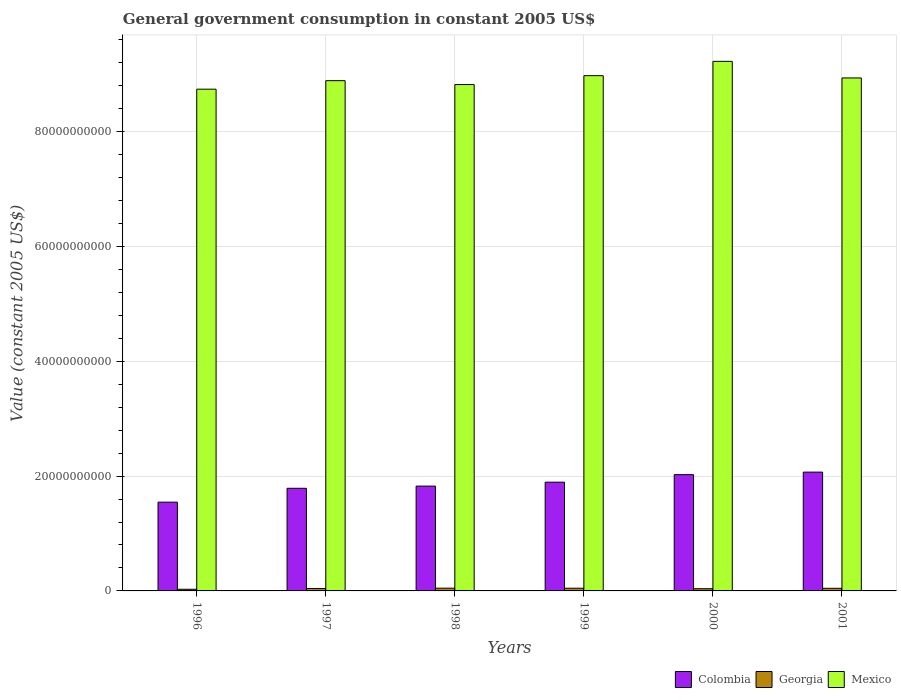How many different coloured bars are there?
Give a very brief answer. 3. Are the number of bars per tick equal to the number of legend labels?
Offer a very short reply. Yes. Are the number of bars on each tick of the X-axis equal?
Make the answer very short. Yes. What is the label of the 3rd group of bars from the left?
Ensure brevity in your answer.  1998. In how many cases, is the number of bars for a given year not equal to the number of legend labels?
Offer a very short reply. 0. What is the government conusmption in Georgia in 1999?
Provide a succinct answer. 4.70e+08. Across all years, what is the maximum government conusmption in Georgia?
Provide a succinct answer. 4.76e+08. Across all years, what is the minimum government conusmption in Mexico?
Ensure brevity in your answer.  8.74e+1. In which year was the government conusmption in Georgia minimum?
Provide a short and direct response. 1996. What is the total government conusmption in Colombia in the graph?
Your answer should be very brief. 1.11e+11. What is the difference between the government conusmption in Georgia in 1997 and that in 2000?
Provide a short and direct response. 3.94e+07. What is the difference between the government conusmption in Mexico in 2000 and the government conusmption in Colombia in 2001?
Offer a very short reply. 7.15e+1. What is the average government conusmption in Mexico per year?
Offer a very short reply. 8.93e+1. In the year 1997, what is the difference between the government conusmption in Georgia and government conusmption in Colombia?
Offer a very short reply. -1.75e+1. What is the ratio of the government conusmption in Georgia in 1996 to that in 1999?
Your answer should be compact. 0.62. Is the government conusmption in Mexico in 1997 less than that in 1998?
Make the answer very short. No. What is the difference between the highest and the second highest government conusmption in Colombia?
Give a very brief answer. 4.44e+08. What is the difference between the highest and the lowest government conusmption in Mexico?
Offer a terse response. 4.85e+09. In how many years, is the government conusmption in Mexico greater than the average government conusmption in Mexico taken over all years?
Ensure brevity in your answer.  3. Is the sum of the government conusmption in Georgia in 2000 and 2001 greater than the maximum government conusmption in Mexico across all years?
Provide a short and direct response. No. What does the 2nd bar from the left in 2001 represents?
Your answer should be very brief. Georgia. What does the 1st bar from the right in 2001 represents?
Your answer should be compact. Mexico. How many bars are there?
Provide a succinct answer. 18. Are all the bars in the graph horizontal?
Give a very brief answer. No. What is the difference between two consecutive major ticks on the Y-axis?
Your response must be concise. 2.00e+1. Are the values on the major ticks of Y-axis written in scientific E-notation?
Give a very brief answer. No. Where does the legend appear in the graph?
Your answer should be very brief. Bottom right. What is the title of the graph?
Provide a short and direct response. General government consumption in constant 2005 US$. Does "Kyrgyz Republic" appear as one of the legend labels in the graph?
Your response must be concise. No. What is the label or title of the Y-axis?
Your answer should be very brief. Value (constant 2005 US$). What is the Value (constant 2005 US$) of Colombia in 1996?
Offer a very short reply. 1.55e+1. What is the Value (constant 2005 US$) in Georgia in 1996?
Offer a terse response. 2.90e+08. What is the Value (constant 2005 US$) in Mexico in 1996?
Your answer should be compact. 8.74e+1. What is the Value (constant 2005 US$) of Colombia in 1997?
Your answer should be compact. 1.79e+1. What is the Value (constant 2005 US$) of Georgia in 1997?
Your answer should be compact. 4.24e+08. What is the Value (constant 2005 US$) of Mexico in 1997?
Make the answer very short. 8.89e+1. What is the Value (constant 2005 US$) of Colombia in 1998?
Keep it short and to the point. 1.83e+1. What is the Value (constant 2005 US$) of Georgia in 1998?
Your answer should be compact. 4.76e+08. What is the Value (constant 2005 US$) in Mexico in 1998?
Ensure brevity in your answer.  8.82e+1. What is the Value (constant 2005 US$) of Colombia in 1999?
Provide a short and direct response. 1.89e+1. What is the Value (constant 2005 US$) in Georgia in 1999?
Give a very brief answer. 4.70e+08. What is the Value (constant 2005 US$) in Mexico in 1999?
Offer a very short reply. 8.98e+1. What is the Value (constant 2005 US$) of Colombia in 2000?
Give a very brief answer. 2.03e+1. What is the Value (constant 2005 US$) of Georgia in 2000?
Provide a succinct answer. 3.84e+08. What is the Value (constant 2005 US$) of Mexico in 2000?
Make the answer very short. 9.22e+1. What is the Value (constant 2005 US$) of Colombia in 2001?
Offer a terse response. 2.07e+1. What is the Value (constant 2005 US$) of Georgia in 2001?
Your answer should be very brief. 4.55e+08. What is the Value (constant 2005 US$) in Mexico in 2001?
Ensure brevity in your answer.  8.94e+1. Across all years, what is the maximum Value (constant 2005 US$) in Colombia?
Ensure brevity in your answer.  2.07e+1. Across all years, what is the maximum Value (constant 2005 US$) of Georgia?
Offer a terse response. 4.76e+08. Across all years, what is the maximum Value (constant 2005 US$) in Mexico?
Ensure brevity in your answer.  9.22e+1. Across all years, what is the minimum Value (constant 2005 US$) of Colombia?
Offer a terse response. 1.55e+1. Across all years, what is the minimum Value (constant 2005 US$) of Georgia?
Offer a terse response. 2.90e+08. Across all years, what is the minimum Value (constant 2005 US$) in Mexico?
Keep it short and to the point. 8.74e+1. What is the total Value (constant 2005 US$) of Colombia in the graph?
Offer a terse response. 1.11e+11. What is the total Value (constant 2005 US$) in Georgia in the graph?
Ensure brevity in your answer.  2.50e+09. What is the total Value (constant 2005 US$) of Mexico in the graph?
Give a very brief answer. 5.36e+11. What is the difference between the Value (constant 2005 US$) of Colombia in 1996 and that in 1997?
Give a very brief answer. -2.42e+09. What is the difference between the Value (constant 2005 US$) in Georgia in 1996 and that in 1997?
Provide a short and direct response. -1.34e+08. What is the difference between the Value (constant 2005 US$) of Mexico in 1996 and that in 1997?
Provide a short and direct response. -1.48e+09. What is the difference between the Value (constant 2005 US$) of Colombia in 1996 and that in 1998?
Keep it short and to the point. -2.80e+09. What is the difference between the Value (constant 2005 US$) in Georgia in 1996 and that in 1998?
Provide a succinct answer. -1.86e+08. What is the difference between the Value (constant 2005 US$) of Mexico in 1996 and that in 1998?
Your response must be concise. -8.05e+08. What is the difference between the Value (constant 2005 US$) of Colombia in 1996 and that in 1999?
Give a very brief answer. -3.48e+09. What is the difference between the Value (constant 2005 US$) in Georgia in 1996 and that in 1999?
Your answer should be compact. -1.80e+08. What is the difference between the Value (constant 2005 US$) in Mexico in 1996 and that in 1999?
Your answer should be compact. -2.35e+09. What is the difference between the Value (constant 2005 US$) of Colombia in 1996 and that in 2000?
Ensure brevity in your answer.  -4.79e+09. What is the difference between the Value (constant 2005 US$) in Georgia in 1996 and that in 2000?
Offer a very short reply. -9.41e+07. What is the difference between the Value (constant 2005 US$) of Mexico in 1996 and that in 2000?
Your answer should be very brief. -4.85e+09. What is the difference between the Value (constant 2005 US$) of Colombia in 1996 and that in 2001?
Provide a short and direct response. -5.23e+09. What is the difference between the Value (constant 2005 US$) of Georgia in 1996 and that in 2001?
Make the answer very short. -1.65e+08. What is the difference between the Value (constant 2005 US$) of Mexico in 1996 and that in 2001?
Keep it short and to the point. -1.96e+09. What is the difference between the Value (constant 2005 US$) in Colombia in 1997 and that in 1998?
Your answer should be compact. -3.82e+08. What is the difference between the Value (constant 2005 US$) of Georgia in 1997 and that in 1998?
Offer a terse response. -5.24e+07. What is the difference between the Value (constant 2005 US$) of Mexico in 1997 and that in 1998?
Your answer should be compact. 6.76e+08. What is the difference between the Value (constant 2005 US$) in Colombia in 1997 and that in 1999?
Offer a very short reply. -1.07e+09. What is the difference between the Value (constant 2005 US$) of Georgia in 1997 and that in 1999?
Your answer should be very brief. -4.62e+07. What is the difference between the Value (constant 2005 US$) in Mexico in 1997 and that in 1999?
Your answer should be very brief. -8.73e+08. What is the difference between the Value (constant 2005 US$) of Colombia in 1997 and that in 2000?
Offer a terse response. -2.38e+09. What is the difference between the Value (constant 2005 US$) in Georgia in 1997 and that in 2000?
Ensure brevity in your answer.  3.94e+07. What is the difference between the Value (constant 2005 US$) in Mexico in 1997 and that in 2000?
Give a very brief answer. -3.36e+09. What is the difference between the Value (constant 2005 US$) of Colombia in 1997 and that in 2001?
Provide a short and direct response. -2.82e+09. What is the difference between the Value (constant 2005 US$) of Georgia in 1997 and that in 2001?
Offer a terse response. -3.12e+07. What is the difference between the Value (constant 2005 US$) of Mexico in 1997 and that in 2001?
Your answer should be very brief. -4.74e+08. What is the difference between the Value (constant 2005 US$) of Colombia in 1998 and that in 1999?
Keep it short and to the point. -6.83e+08. What is the difference between the Value (constant 2005 US$) of Georgia in 1998 and that in 1999?
Provide a succinct answer. 6.24e+06. What is the difference between the Value (constant 2005 US$) in Mexico in 1998 and that in 1999?
Give a very brief answer. -1.55e+09. What is the difference between the Value (constant 2005 US$) in Colombia in 1998 and that in 2000?
Your answer should be compact. -1.99e+09. What is the difference between the Value (constant 2005 US$) in Georgia in 1998 and that in 2000?
Offer a very short reply. 9.19e+07. What is the difference between the Value (constant 2005 US$) of Mexico in 1998 and that in 2000?
Your answer should be compact. -4.04e+09. What is the difference between the Value (constant 2005 US$) in Colombia in 1998 and that in 2001?
Give a very brief answer. -2.44e+09. What is the difference between the Value (constant 2005 US$) of Georgia in 1998 and that in 2001?
Make the answer very short. 2.13e+07. What is the difference between the Value (constant 2005 US$) in Mexico in 1998 and that in 2001?
Your answer should be very brief. -1.15e+09. What is the difference between the Value (constant 2005 US$) in Colombia in 1999 and that in 2000?
Your answer should be compact. -1.31e+09. What is the difference between the Value (constant 2005 US$) of Georgia in 1999 and that in 2000?
Give a very brief answer. 8.56e+07. What is the difference between the Value (constant 2005 US$) of Mexico in 1999 and that in 2000?
Keep it short and to the point. -2.49e+09. What is the difference between the Value (constant 2005 US$) of Colombia in 1999 and that in 2001?
Offer a very short reply. -1.75e+09. What is the difference between the Value (constant 2005 US$) in Georgia in 1999 and that in 2001?
Keep it short and to the point. 1.50e+07. What is the difference between the Value (constant 2005 US$) of Mexico in 1999 and that in 2001?
Provide a succinct answer. 3.99e+08. What is the difference between the Value (constant 2005 US$) in Colombia in 2000 and that in 2001?
Offer a terse response. -4.44e+08. What is the difference between the Value (constant 2005 US$) in Georgia in 2000 and that in 2001?
Give a very brief answer. -7.06e+07. What is the difference between the Value (constant 2005 US$) in Mexico in 2000 and that in 2001?
Provide a succinct answer. 2.89e+09. What is the difference between the Value (constant 2005 US$) of Colombia in 1996 and the Value (constant 2005 US$) of Georgia in 1997?
Provide a succinct answer. 1.50e+1. What is the difference between the Value (constant 2005 US$) of Colombia in 1996 and the Value (constant 2005 US$) of Mexico in 1997?
Your answer should be compact. -7.34e+1. What is the difference between the Value (constant 2005 US$) of Georgia in 1996 and the Value (constant 2005 US$) of Mexico in 1997?
Provide a short and direct response. -8.86e+1. What is the difference between the Value (constant 2005 US$) in Colombia in 1996 and the Value (constant 2005 US$) in Georgia in 1998?
Offer a very short reply. 1.50e+1. What is the difference between the Value (constant 2005 US$) of Colombia in 1996 and the Value (constant 2005 US$) of Mexico in 1998?
Make the answer very short. -7.27e+1. What is the difference between the Value (constant 2005 US$) in Georgia in 1996 and the Value (constant 2005 US$) in Mexico in 1998?
Your answer should be compact. -8.79e+1. What is the difference between the Value (constant 2005 US$) of Colombia in 1996 and the Value (constant 2005 US$) of Georgia in 1999?
Your answer should be very brief. 1.50e+1. What is the difference between the Value (constant 2005 US$) in Colombia in 1996 and the Value (constant 2005 US$) in Mexico in 1999?
Keep it short and to the point. -7.43e+1. What is the difference between the Value (constant 2005 US$) of Georgia in 1996 and the Value (constant 2005 US$) of Mexico in 1999?
Ensure brevity in your answer.  -8.95e+1. What is the difference between the Value (constant 2005 US$) in Colombia in 1996 and the Value (constant 2005 US$) in Georgia in 2000?
Make the answer very short. 1.51e+1. What is the difference between the Value (constant 2005 US$) of Colombia in 1996 and the Value (constant 2005 US$) of Mexico in 2000?
Your answer should be compact. -7.68e+1. What is the difference between the Value (constant 2005 US$) of Georgia in 1996 and the Value (constant 2005 US$) of Mexico in 2000?
Ensure brevity in your answer.  -9.20e+1. What is the difference between the Value (constant 2005 US$) in Colombia in 1996 and the Value (constant 2005 US$) in Georgia in 2001?
Provide a succinct answer. 1.50e+1. What is the difference between the Value (constant 2005 US$) of Colombia in 1996 and the Value (constant 2005 US$) of Mexico in 2001?
Offer a terse response. -7.39e+1. What is the difference between the Value (constant 2005 US$) of Georgia in 1996 and the Value (constant 2005 US$) of Mexico in 2001?
Make the answer very short. -8.91e+1. What is the difference between the Value (constant 2005 US$) in Colombia in 1997 and the Value (constant 2005 US$) in Georgia in 1998?
Give a very brief answer. 1.74e+1. What is the difference between the Value (constant 2005 US$) of Colombia in 1997 and the Value (constant 2005 US$) of Mexico in 1998?
Offer a terse response. -7.03e+1. What is the difference between the Value (constant 2005 US$) in Georgia in 1997 and the Value (constant 2005 US$) in Mexico in 1998?
Your answer should be very brief. -8.78e+1. What is the difference between the Value (constant 2005 US$) in Colombia in 1997 and the Value (constant 2005 US$) in Georgia in 1999?
Provide a short and direct response. 1.74e+1. What is the difference between the Value (constant 2005 US$) in Colombia in 1997 and the Value (constant 2005 US$) in Mexico in 1999?
Your response must be concise. -7.19e+1. What is the difference between the Value (constant 2005 US$) of Georgia in 1997 and the Value (constant 2005 US$) of Mexico in 1999?
Provide a succinct answer. -8.93e+1. What is the difference between the Value (constant 2005 US$) in Colombia in 1997 and the Value (constant 2005 US$) in Georgia in 2000?
Provide a short and direct response. 1.75e+1. What is the difference between the Value (constant 2005 US$) in Colombia in 1997 and the Value (constant 2005 US$) in Mexico in 2000?
Provide a succinct answer. -7.44e+1. What is the difference between the Value (constant 2005 US$) in Georgia in 1997 and the Value (constant 2005 US$) in Mexico in 2000?
Keep it short and to the point. -9.18e+1. What is the difference between the Value (constant 2005 US$) of Colombia in 1997 and the Value (constant 2005 US$) of Georgia in 2001?
Provide a succinct answer. 1.74e+1. What is the difference between the Value (constant 2005 US$) of Colombia in 1997 and the Value (constant 2005 US$) of Mexico in 2001?
Make the answer very short. -7.15e+1. What is the difference between the Value (constant 2005 US$) of Georgia in 1997 and the Value (constant 2005 US$) of Mexico in 2001?
Keep it short and to the point. -8.89e+1. What is the difference between the Value (constant 2005 US$) in Colombia in 1998 and the Value (constant 2005 US$) in Georgia in 1999?
Keep it short and to the point. 1.78e+1. What is the difference between the Value (constant 2005 US$) in Colombia in 1998 and the Value (constant 2005 US$) in Mexico in 1999?
Make the answer very short. -7.15e+1. What is the difference between the Value (constant 2005 US$) of Georgia in 1998 and the Value (constant 2005 US$) of Mexico in 1999?
Give a very brief answer. -8.93e+1. What is the difference between the Value (constant 2005 US$) in Colombia in 1998 and the Value (constant 2005 US$) in Georgia in 2000?
Offer a terse response. 1.79e+1. What is the difference between the Value (constant 2005 US$) of Colombia in 1998 and the Value (constant 2005 US$) of Mexico in 2000?
Your answer should be compact. -7.40e+1. What is the difference between the Value (constant 2005 US$) in Georgia in 1998 and the Value (constant 2005 US$) in Mexico in 2000?
Keep it short and to the point. -9.18e+1. What is the difference between the Value (constant 2005 US$) in Colombia in 1998 and the Value (constant 2005 US$) in Georgia in 2001?
Your response must be concise. 1.78e+1. What is the difference between the Value (constant 2005 US$) of Colombia in 1998 and the Value (constant 2005 US$) of Mexico in 2001?
Provide a succinct answer. -7.11e+1. What is the difference between the Value (constant 2005 US$) in Georgia in 1998 and the Value (constant 2005 US$) in Mexico in 2001?
Offer a terse response. -8.89e+1. What is the difference between the Value (constant 2005 US$) of Colombia in 1999 and the Value (constant 2005 US$) of Georgia in 2000?
Your answer should be compact. 1.86e+1. What is the difference between the Value (constant 2005 US$) in Colombia in 1999 and the Value (constant 2005 US$) in Mexico in 2000?
Make the answer very short. -7.33e+1. What is the difference between the Value (constant 2005 US$) of Georgia in 1999 and the Value (constant 2005 US$) of Mexico in 2000?
Provide a succinct answer. -9.18e+1. What is the difference between the Value (constant 2005 US$) in Colombia in 1999 and the Value (constant 2005 US$) in Georgia in 2001?
Provide a succinct answer. 1.85e+1. What is the difference between the Value (constant 2005 US$) in Colombia in 1999 and the Value (constant 2005 US$) in Mexico in 2001?
Keep it short and to the point. -7.04e+1. What is the difference between the Value (constant 2005 US$) in Georgia in 1999 and the Value (constant 2005 US$) in Mexico in 2001?
Give a very brief answer. -8.89e+1. What is the difference between the Value (constant 2005 US$) in Colombia in 2000 and the Value (constant 2005 US$) in Georgia in 2001?
Offer a terse response. 1.98e+1. What is the difference between the Value (constant 2005 US$) in Colombia in 2000 and the Value (constant 2005 US$) in Mexico in 2001?
Your answer should be very brief. -6.91e+1. What is the difference between the Value (constant 2005 US$) of Georgia in 2000 and the Value (constant 2005 US$) of Mexico in 2001?
Your response must be concise. -8.90e+1. What is the average Value (constant 2005 US$) of Colombia per year?
Offer a terse response. 1.86e+1. What is the average Value (constant 2005 US$) of Georgia per year?
Offer a terse response. 4.17e+08. What is the average Value (constant 2005 US$) in Mexico per year?
Offer a very short reply. 8.93e+1. In the year 1996, what is the difference between the Value (constant 2005 US$) of Colombia and Value (constant 2005 US$) of Georgia?
Offer a very short reply. 1.52e+1. In the year 1996, what is the difference between the Value (constant 2005 US$) in Colombia and Value (constant 2005 US$) in Mexico?
Keep it short and to the point. -7.19e+1. In the year 1996, what is the difference between the Value (constant 2005 US$) in Georgia and Value (constant 2005 US$) in Mexico?
Provide a short and direct response. -8.71e+1. In the year 1997, what is the difference between the Value (constant 2005 US$) of Colombia and Value (constant 2005 US$) of Georgia?
Provide a succinct answer. 1.75e+1. In the year 1997, what is the difference between the Value (constant 2005 US$) in Colombia and Value (constant 2005 US$) in Mexico?
Give a very brief answer. -7.10e+1. In the year 1997, what is the difference between the Value (constant 2005 US$) in Georgia and Value (constant 2005 US$) in Mexico?
Provide a succinct answer. -8.85e+1. In the year 1998, what is the difference between the Value (constant 2005 US$) in Colombia and Value (constant 2005 US$) in Georgia?
Ensure brevity in your answer.  1.78e+1. In the year 1998, what is the difference between the Value (constant 2005 US$) in Colombia and Value (constant 2005 US$) in Mexico?
Your answer should be compact. -6.99e+1. In the year 1998, what is the difference between the Value (constant 2005 US$) of Georgia and Value (constant 2005 US$) of Mexico?
Provide a succinct answer. -8.77e+1. In the year 1999, what is the difference between the Value (constant 2005 US$) of Colombia and Value (constant 2005 US$) of Georgia?
Keep it short and to the point. 1.85e+1. In the year 1999, what is the difference between the Value (constant 2005 US$) of Colombia and Value (constant 2005 US$) of Mexico?
Give a very brief answer. -7.08e+1. In the year 1999, what is the difference between the Value (constant 2005 US$) in Georgia and Value (constant 2005 US$) in Mexico?
Your answer should be compact. -8.93e+1. In the year 2000, what is the difference between the Value (constant 2005 US$) of Colombia and Value (constant 2005 US$) of Georgia?
Your response must be concise. 1.99e+1. In the year 2000, what is the difference between the Value (constant 2005 US$) of Colombia and Value (constant 2005 US$) of Mexico?
Provide a succinct answer. -7.20e+1. In the year 2000, what is the difference between the Value (constant 2005 US$) in Georgia and Value (constant 2005 US$) in Mexico?
Keep it short and to the point. -9.19e+1. In the year 2001, what is the difference between the Value (constant 2005 US$) of Colombia and Value (constant 2005 US$) of Georgia?
Provide a short and direct response. 2.02e+1. In the year 2001, what is the difference between the Value (constant 2005 US$) of Colombia and Value (constant 2005 US$) of Mexico?
Ensure brevity in your answer.  -6.87e+1. In the year 2001, what is the difference between the Value (constant 2005 US$) in Georgia and Value (constant 2005 US$) in Mexico?
Keep it short and to the point. -8.89e+1. What is the ratio of the Value (constant 2005 US$) of Colombia in 1996 to that in 1997?
Keep it short and to the point. 0.86. What is the ratio of the Value (constant 2005 US$) of Georgia in 1996 to that in 1997?
Offer a very short reply. 0.69. What is the ratio of the Value (constant 2005 US$) in Mexico in 1996 to that in 1997?
Make the answer very short. 0.98. What is the ratio of the Value (constant 2005 US$) in Colombia in 1996 to that in 1998?
Keep it short and to the point. 0.85. What is the ratio of the Value (constant 2005 US$) in Georgia in 1996 to that in 1998?
Make the answer very short. 0.61. What is the ratio of the Value (constant 2005 US$) in Mexico in 1996 to that in 1998?
Keep it short and to the point. 0.99. What is the ratio of the Value (constant 2005 US$) in Colombia in 1996 to that in 1999?
Your response must be concise. 0.82. What is the ratio of the Value (constant 2005 US$) in Georgia in 1996 to that in 1999?
Your answer should be very brief. 0.62. What is the ratio of the Value (constant 2005 US$) of Mexico in 1996 to that in 1999?
Keep it short and to the point. 0.97. What is the ratio of the Value (constant 2005 US$) of Colombia in 1996 to that in 2000?
Keep it short and to the point. 0.76. What is the ratio of the Value (constant 2005 US$) in Georgia in 1996 to that in 2000?
Offer a terse response. 0.76. What is the ratio of the Value (constant 2005 US$) of Mexico in 1996 to that in 2000?
Your answer should be very brief. 0.95. What is the ratio of the Value (constant 2005 US$) in Colombia in 1996 to that in 2001?
Give a very brief answer. 0.75. What is the ratio of the Value (constant 2005 US$) in Georgia in 1996 to that in 2001?
Ensure brevity in your answer.  0.64. What is the ratio of the Value (constant 2005 US$) in Mexico in 1996 to that in 2001?
Your answer should be very brief. 0.98. What is the ratio of the Value (constant 2005 US$) of Colombia in 1997 to that in 1998?
Keep it short and to the point. 0.98. What is the ratio of the Value (constant 2005 US$) of Georgia in 1997 to that in 1998?
Make the answer very short. 0.89. What is the ratio of the Value (constant 2005 US$) of Mexico in 1997 to that in 1998?
Provide a succinct answer. 1.01. What is the ratio of the Value (constant 2005 US$) of Colombia in 1997 to that in 1999?
Keep it short and to the point. 0.94. What is the ratio of the Value (constant 2005 US$) of Georgia in 1997 to that in 1999?
Your response must be concise. 0.9. What is the ratio of the Value (constant 2005 US$) in Mexico in 1997 to that in 1999?
Make the answer very short. 0.99. What is the ratio of the Value (constant 2005 US$) of Colombia in 1997 to that in 2000?
Provide a succinct answer. 0.88. What is the ratio of the Value (constant 2005 US$) in Georgia in 1997 to that in 2000?
Your answer should be compact. 1.1. What is the ratio of the Value (constant 2005 US$) of Mexico in 1997 to that in 2000?
Your answer should be compact. 0.96. What is the ratio of the Value (constant 2005 US$) of Colombia in 1997 to that in 2001?
Provide a short and direct response. 0.86. What is the ratio of the Value (constant 2005 US$) in Georgia in 1997 to that in 2001?
Provide a succinct answer. 0.93. What is the ratio of the Value (constant 2005 US$) in Colombia in 1998 to that in 1999?
Make the answer very short. 0.96. What is the ratio of the Value (constant 2005 US$) in Georgia in 1998 to that in 1999?
Your response must be concise. 1.01. What is the ratio of the Value (constant 2005 US$) of Mexico in 1998 to that in 1999?
Keep it short and to the point. 0.98. What is the ratio of the Value (constant 2005 US$) in Colombia in 1998 to that in 2000?
Your answer should be very brief. 0.9. What is the ratio of the Value (constant 2005 US$) in Georgia in 1998 to that in 2000?
Provide a succinct answer. 1.24. What is the ratio of the Value (constant 2005 US$) of Mexico in 1998 to that in 2000?
Ensure brevity in your answer.  0.96. What is the ratio of the Value (constant 2005 US$) in Colombia in 1998 to that in 2001?
Your answer should be very brief. 0.88. What is the ratio of the Value (constant 2005 US$) of Georgia in 1998 to that in 2001?
Provide a short and direct response. 1.05. What is the ratio of the Value (constant 2005 US$) of Mexico in 1998 to that in 2001?
Your response must be concise. 0.99. What is the ratio of the Value (constant 2005 US$) in Colombia in 1999 to that in 2000?
Your response must be concise. 0.94. What is the ratio of the Value (constant 2005 US$) of Georgia in 1999 to that in 2000?
Your response must be concise. 1.22. What is the ratio of the Value (constant 2005 US$) of Colombia in 1999 to that in 2001?
Keep it short and to the point. 0.92. What is the ratio of the Value (constant 2005 US$) in Georgia in 1999 to that in 2001?
Your answer should be compact. 1.03. What is the ratio of the Value (constant 2005 US$) of Colombia in 2000 to that in 2001?
Your response must be concise. 0.98. What is the ratio of the Value (constant 2005 US$) in Georgia in 2000 to that in 2001?
Your answer should be very brief. 0.84. What is the ratio of the Value (constant 2005 US$) in Mexico in 2000 to that in 2001?
Ensure brevity in your answer.  1.03. What is the difference between the highest and the second highest Value (constant 2005 US$) of Colombia?
Your answer should be compact. 4.44e+08. What is the difference between the highest and the second highest Value (constant 2005 US$) of Georgia?
Provide a succinct answer. 6.24e+06. What is the difference between the highest and the second highest Value (constant 2005 US$) in Mexico?
Make the answer very short. 2.49e+09. What is the difference between the highest and the lowest Value (constant 2005 US$) of Colombia?
Give a very brief answer. 5.23e+09. What is the difference between the highest and the lowest Value (constant 2005 US$) in Georgia?
Make the answer very short. 1.86e+08. What is the difference between the highest and the lowest Value (constant 2005 US$) of Mexico?
Provide a short and direct response. 4.85e+09. 